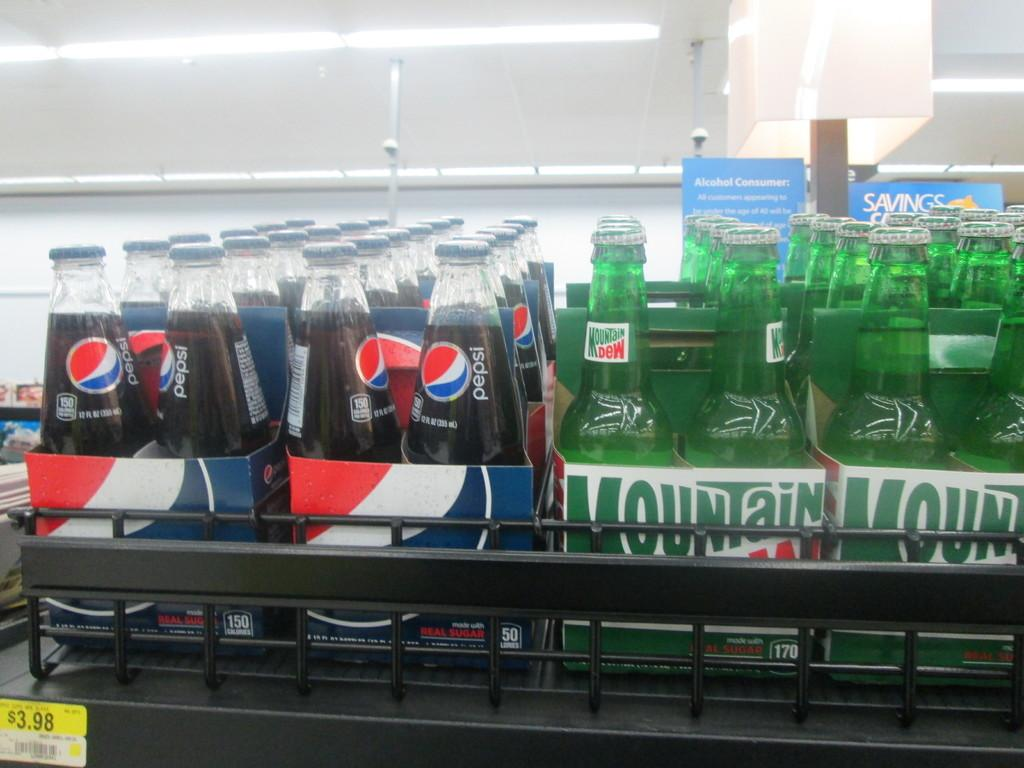<image>
Offer a succinct explanation of the picture presented. Two different brands of beverages with one being Pepsi and the other being Mountain Dew. 